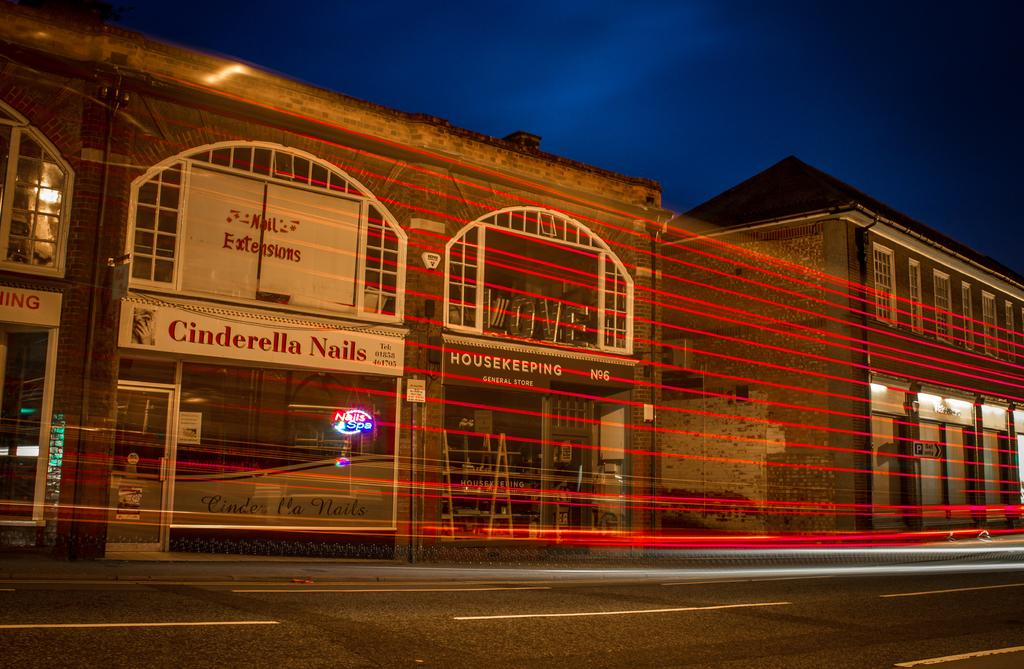What type of structures can be seen in the image? There are buildings in the image. What color lines are present in the image? There are red color lines in the image. What can be seen on the road in the image? There is a road with white lines in the image. What is written on the board in the image? There is a board with writing in the image. What is visible in the background of the image? The sky is visible in the background of the image. What type of music can be heard in the image? There is no music present in the image, so it is not possible to determine what type of music might be heard. 